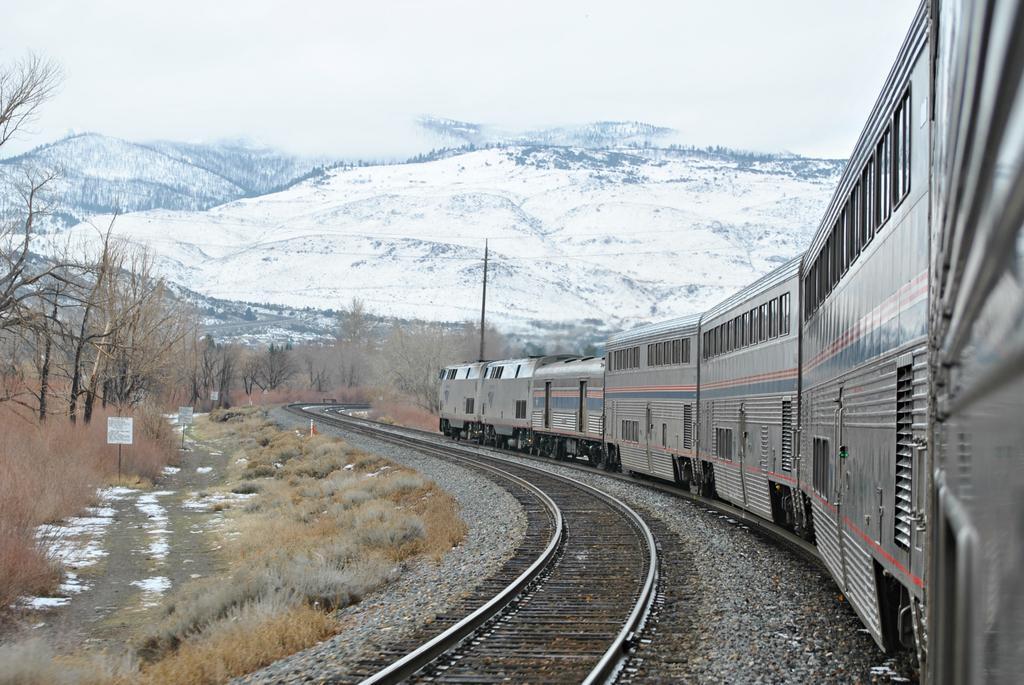Please provide a concise description of this image. In this image we can see a locomotive on the track, an empty track, stones, shrubs, information boards, trees, mountains and sky. 